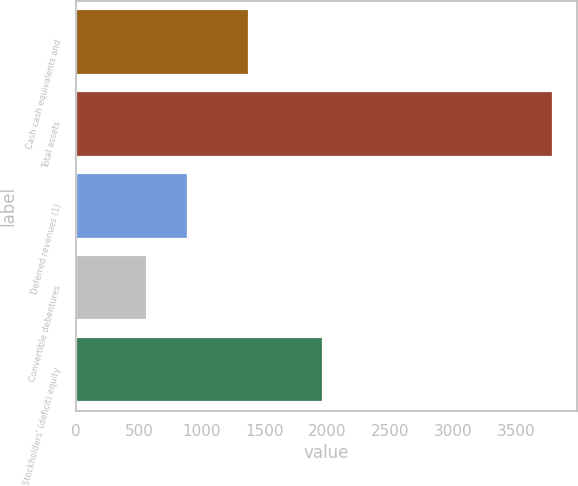<chart> <loc_0><loc_0><loc_500><loc_500><bar_chart><fcel>Cash cash equivalents and<fcel>Total assets<fcel>Deferred revenues (1)<fcel>Convertible debentures<fcel>Stockholders' (deficit) equity<nl><fcel>1377<fcel>3795<fcel>889.8<fcel>567<fcel>1969<nl></chart> 